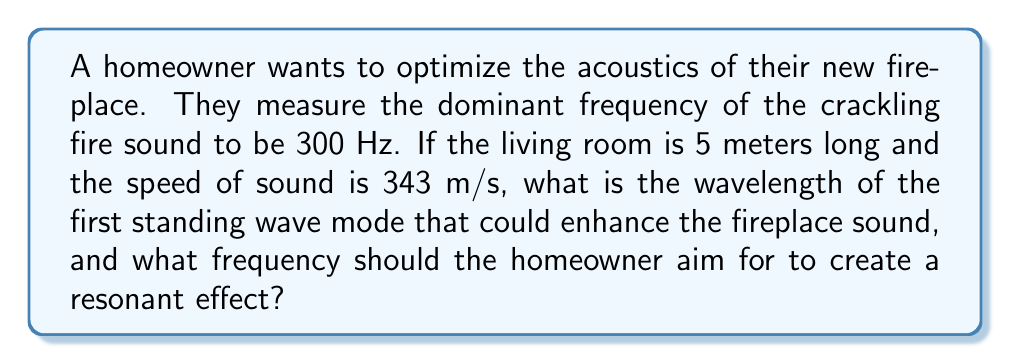Solve this math problem. Let's approach this step-by-step:

1) First, we need to understand that standing waves in a room occur when the room length is equal to half the wavelength, or multiples thereof. For the first mode:

   $L = \frac{\lambda}{2}$, where $L$ is the room length and $\lambda$ is the wavelength.

2) Given the room length $L = 5$ m, we can calculate the wavelength:

   $5 = \frac{\lambda}{2}$
   $\lambda = 2 \times 5 = 10$ m

3) Now that we have the wavelength, we can calculate the frequency of this standing wave using the wave equation:

   $v = f\lambda$

   Where $v$ is the speed of sound (343 m/s), $f$ is the frequency, and $\lambda$ is the wavelength (10 m).

4) Rearranging the equation to solve for $f$:

   $f = \frac{v}{\lambda} = \frac{343}{10} = 34.3$ Hz

5) This 34.3 Hz is the frequency that would create the first standing wave mode in the room, potentially enhancing the fireplace sound.

6) To create a resonant effect, the homeowner should aim for a frequency that is a multiple of this fundamental frequency. The closest multiple to the measured 300 Hz of the fire would be:

   $34.3 \times 9 = 308.7$ Hz

This frequency would create the 9th harmonic standing wave in the room, closely matching the fire's dominant frequency and potentially enhancing the acoustic experience.
Answer: Wavelength: 10 m; Target frequency: 308.7 Hz 